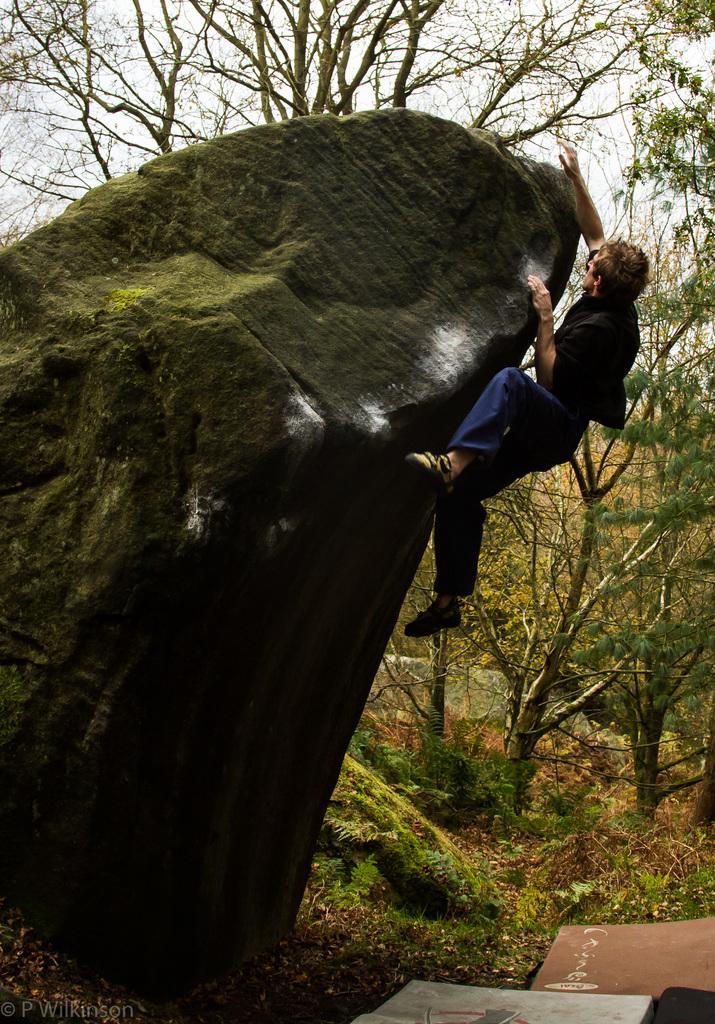Describe this image in one or two sentences. In this image we can see a person climbing a rock. In the background of the image there are trees. At the bottom of the image there is text. 